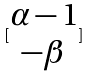<formula> <loc_0><loc_0><loc_500><loc_500>[ \begin{matrix} \alpha - 1 \\ - \beta \end{matrix} ]</formula> 